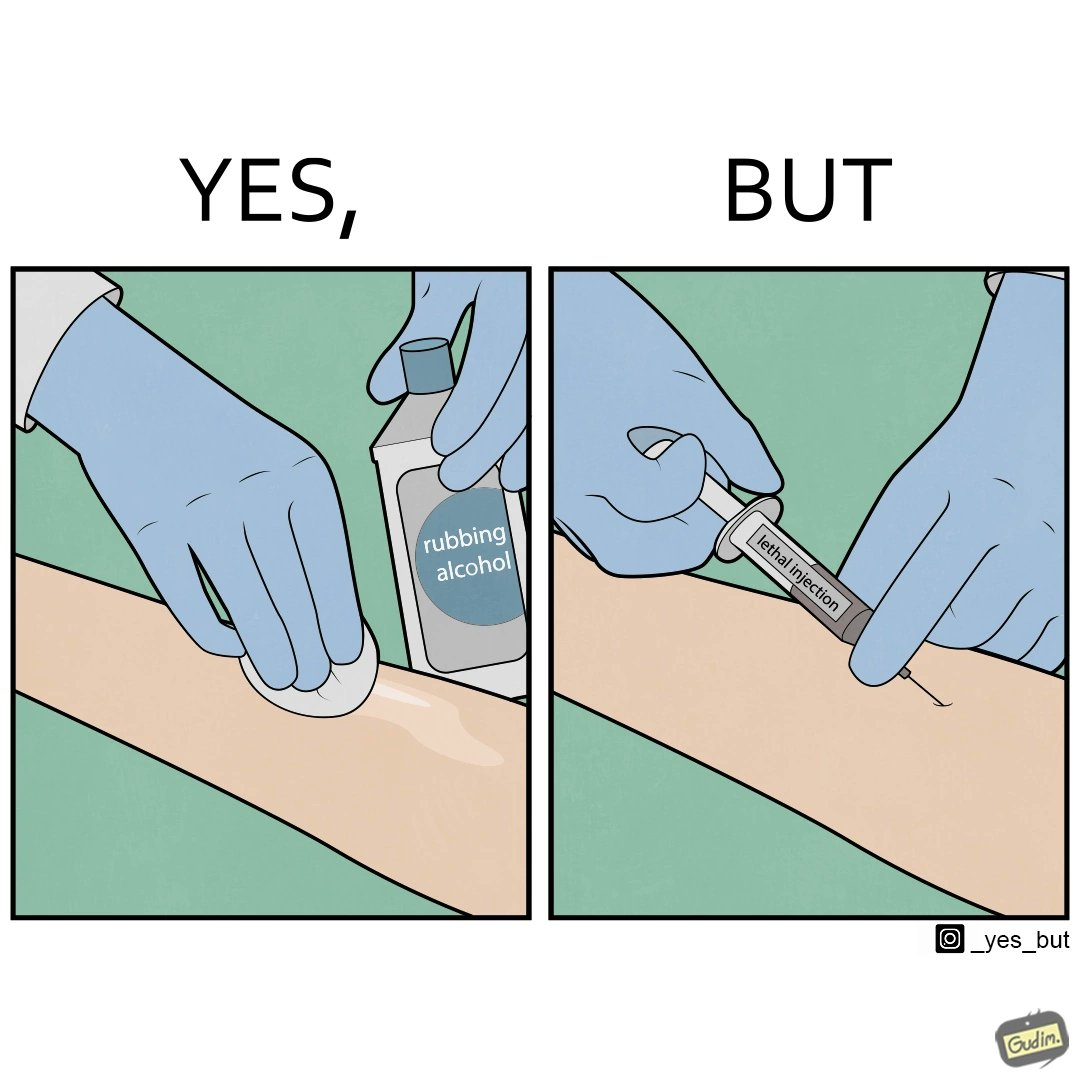Would you classify this image as satirical? Yes, this image is satirical. 